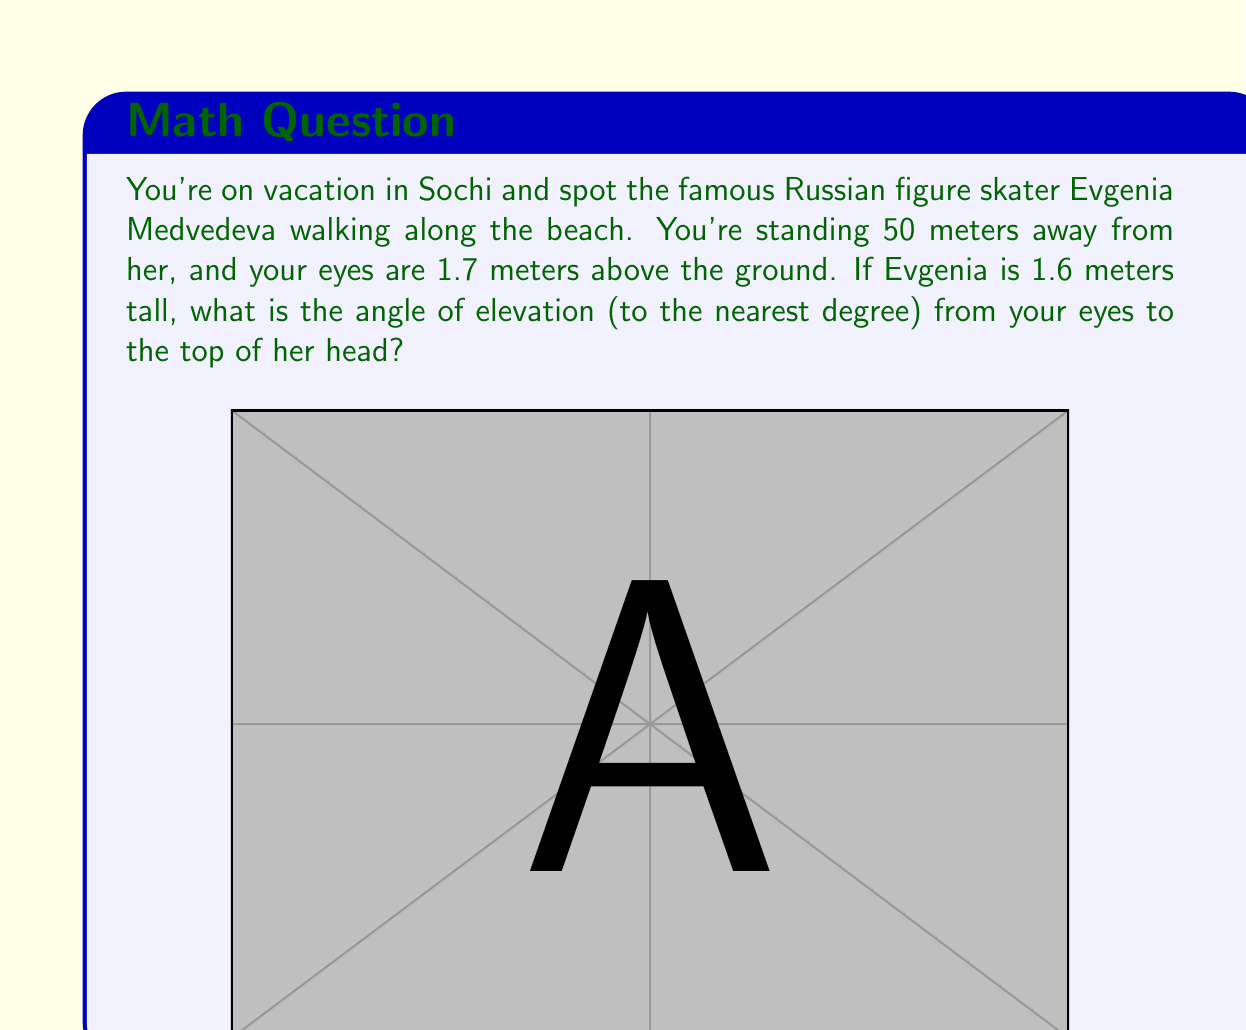What is the answer to this math problem? To solve this problem, we need to use trigonometry. Let's break it down step by step:

1) First, we need to find the height difference between your eyes and the top of Evgenia's head:
   $1.6 \text{ m} - 1.7 \text{ m} = -0.1 \text{ m}$
   This means your eyes are actually 0.1 m higher than the top of her head.

2) Now we have a right triangle. The base of this triangle is 50 m (the horizontal distance), and the height is 0.1 m.

3) We need to find the angle of elevation, which is the angle between the horizontal and the line of sight. Let's call this angle $\theta$.

4) In a right triangle, $\tan(\theta) = \frac{\text{opposite}}{\text{adjacent}}$

5) In our case:
   $\tan(\theta) = \frac{0.1}{50} = 0.002$

6) To find $\theta$, we need to take the inverse tangent (arctan or $\tan^{-1}$):
   $\theta = \tan^{-1}(0.002)$

7) Using a calculator or computer:
   $\theta \approx 0.1146 \text{ radians}$

8) Converting to degrees:
   $\theta \approx 0.1146 \times \frac{180}{\pi} \approx 6.56°$

9) Rounding to the nearest degree:
   $\theta \approx 7°$

Note: The angle is positive because we're looking slightly upward, even though your eyes are higher than Evgenia's head. This is because the angle is measured from the horizontal, not from your eye level.
Answer: The angle of elevation is approximately $7°$. 